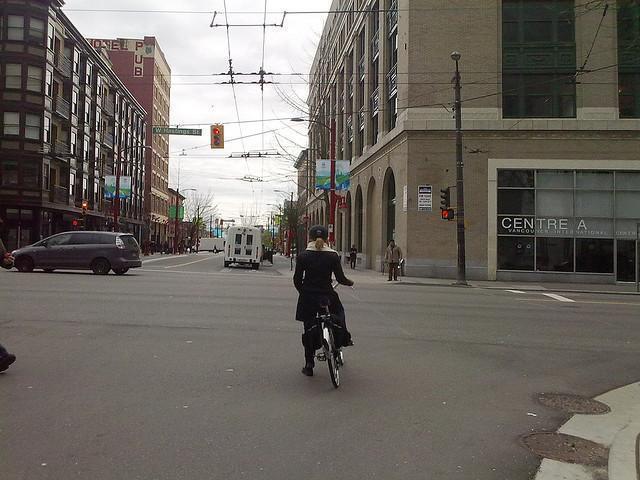What province is she riding in?
From the following set of four choices, select the accurate answer to respond to the question.
Options: Manitoba, alberta, british columbia, ontario. British columbia. 